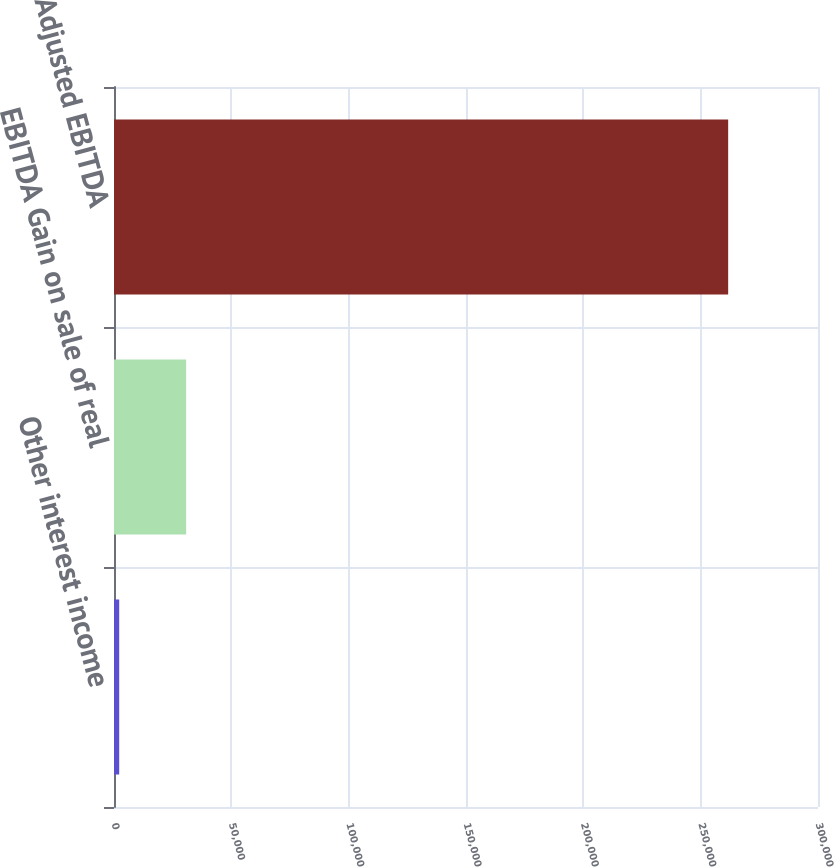<chart> <loc_0><loc_0><loc_500><loc_500><bar_chart><fcel>Other interest income<fcel>EBITDA Gain on sale of real<fcel>Adjusted EBITDA<nl><fcel>2216<fcel>30748<fcel>261717<nl></chart> 